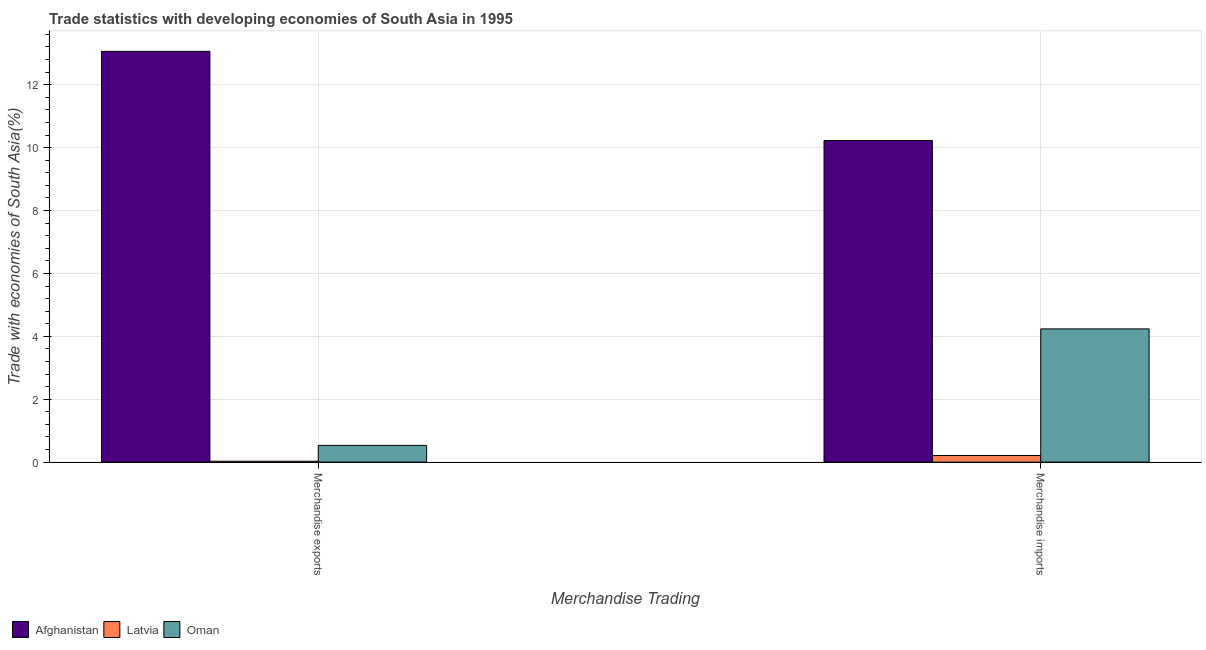How many groups of bars are there?
Give a very brief answer. 2. Are the number of bars per tick equal to the number of legend labels?
Your answer should be compact. Yes. Are the number of bars on each tick of the X-axis equal?
Provide a succinct answer. Yes. What is the label of the 2nd group of bars from the left?
Your response must be concise. Merchandise imports. What is the merchandise exports in Latvia?
Offer a terse response. 0.03. Across all countries, what is the maximum merchandise imports?
Offer a very short reply. 10.23. Across all countries, what is the minimum merchandise exports?
Your answer should be very brief. 0.03. In which country was the merchandise imports maximum?
Make the answer very short. Afghanistan. In which country was the merchandise imports minimum?
Your answer should be compact. Latvia. What is the total merchandise exports in the graph?
Ensure brevity in your answer.  13.62. What is the difference between the merchandise imports in Afghanistan and that in Latvia?
Your response must be concise. 10.02. What is the difference between the merchandise exports in Afghanistan and the merchandise imports in Oman?
Ensure brevity in your answer.  8.82. What is the average merchandise imports per country?
Ensure brevity in your answer.  4.89. What is the difference between the merchandise imports and merchandise exports in Oman?
Provide a short and direct response. 3.7. In how many countries, is the merchandise imports greater than 12.8 %?
Provide a succinct answer. 0. What is the ratio of the merchandise imports in Oman to that in Latvia?
Your answer should be very brief. 20.19. What does the 1st bar from the left in Merchandise exports represents?
Your answer should be very brief. Afghanistan. What does the 1st bar from the right in Merchandise exports represents?
Your answer should be very brief. Oman. How many bars are there?
Your response must be concise. 6. How many countries are there in the graph?
Your response must be concise. 3. What is the difference between two consecutive major ticks on the Y-axis?
Keep it short and to the point. 2. Does the graph contain any zero values?
Give a very brief answer. No. Where does the legend appear in the graph?
Make the answer very short. Bottom left. How are the legend labels stacked?
Offer a terse response. Horizontal. What is the title of the graph?
Provide a succinct answer. Trade statistics with developing economies of South Asia in 1995. What is the label or title of the X-axis?
Ensure brevity in your answer.  Merchandise Trading. What is the label or title of the Y-axis?
Give a very brief answer. Trade with economies of South Asia(%). What is the Trade with economies of South Asia(%) in Afghanistan in Merchandise exports?
Your answer should be very brief. 13.06. What is the Trade with economies of South Asia(%) in Latvia in Merchandise exports?
Ensure brevity in your answer.  0.03. What is the Trade with economies of South Asia(%) in Oman in Merchandise exports?
Ensure brevity in your answer.  0.53. What is the Trade with economies of South Asia(%) in Afghanistan in Merchandise imports?
Your answer should be very brief. 10.23. What is the Trade with economies of South Asia(%) in Latvia in Merchandise imports?
Offer a terse response. 0.21. What is the Trade with economies of South Asia(%) of Oman in Merchandise imports?
Offer a very short reply. 4.24. Across all Merchandise Trading, what is the maximum Trade with economies of South Asia(%) in Afghanistan?
Give a very brief answer. 13.06. Across all Merchandise Trading, what is the maximum Trade with economies of South Asia(%) in Latvia?
Make the answer very short. 0.21. Across all Merchandise Trading, what is the maximum Trade with economies of South Asia(%) of Oman?
Offer a terse response. 4.24. Across all Merchandise Trading, what is the minimum Trade with economies of South Asia(%) in Afghanistan?
Your response must be concise. 10.23. Across all Merchandise Trading, what is the minimum Trade with economies of South Asia(%) in Latvia?
Offer a terse response. 0.03. Across all Merchandise Trading, what is the minimum Trade with economies of South Asia(%) in Oman?
Offer a very short reply. 0.53. What is the total Trade with economies of South Asia(%) of Afghanistan in the graph?
Provide a succinct answer. 23.29. What is the total Trade with economies of South Asia(%) of Latvia in the graph?
Give a very brief answer. 0.24. What is the total Trade with economies of South Asia(%) in Oman in the graph?
Make the answer very short. 4.77. What is the difference between the Trade with economies of South Asia(%) in Afghanistan in Merchandise exports and that in Merchandise imports?
Your answer should be very brief. 2.83. What is the difference between the Trade with economies of South Asia(%) in Latvia in Merchandise exports and that in Merchandise imports?
Offer a terse response. -0.18. What is the difference between the Trade with economies of South Asia(%) in Oman in Merchandise exports and that in Merchandise imports?
Your response must be concise. -3.7. What is the difference between the Trade with economies of South Asia(%) in Afghanistan in Merchandise exports and the Trade with economies of South Asia(%) in Latvia in Merchandise imports?
Offer a very short reply. 12.85. What is the difference between the Trade with economies of South Asia(%) of Afghanistan in Merchandise exports and the Trade with economies of South Asia(%) of Oman in Merchandise imports?
Your response must be concise. 8.82. What is the difference between the Trade with economies of South Asia(%) in Latvia in Merchandise exports and the Trade with economies of South Asia(%) in Oman in Merchandise imports?
Keep it short and to the point. -4.21. What is the average Trade with economies of South Asia(%) in Afghanistan per Merchandise Trading?
Your answer should be compact. 11.64. What is the average Trade with economies of South Asia(%) in Latvia per Merchandise Trading?
Offer a terse response. 0.12. What is the average Trade with economies of South Asia(%) in Oman per Merchandise Trading?
Offer a terse response. 2.38. What is the difference between the Trade with economies of South Asia(%) of Afghanistan and Trade with economies of South Asia(%) of Latvia in Merchandise exports?
Provide a short and direct response. 13.03. What is the difference between the Trade with economies of South Asia(%) of Afghanistan and Trade with economies of South Asia(%) of Oman in Merchandise exports?
Your response must be concise. 12.53. What is the difference between the Trade with economies of South Asia(%) in Latvia and Trade with economies of South Asia(%) in Oman in Merchandise exports?
Keep it short and to the point. -0.5. What is the difference between the Trade with economies of South Asia(%) of Afghanistan and Trade with economies of South Asia(%) of Latvia in Merchandise imports?
Your response must be concise. 10.02. What is the difference between the Trade with economies of South Asia(%) of Afghanistan and Trade with economies of South Asia(%) of Oman in Merchandise imports?
Provide a succinct answer. 5.99. What is the difference between the Trade with economies of South Asia(%) in Latvia and Trade with economies of South Asia(%) in Oman in Merchandise imports?
Offer a very short reply. -4.03. What is the ratio of the Trade with economies of South Asia(%) in Afghanistan in Merchandise exports to that in Merchandise imports?
Your response must be concise. 1.28. What is the ratio of the Trade with economies of South Asia(%) in Latvia in Merchandise exports to that in Merchandise imports?
Your answer should be very brief. 0.14. What is the ratio of the Trade with economies of South Asia(%) of Oman in Merchandise exports to that in Merchandise imports?
Ensure brevity in your answer.  0.13. What is the difference between the highest and the second highest Trade with economies of South Asia(%) in Afghanistan?
Make the answer very short. 2.83. What is the difference between the highest and the second highest Trade with economies of South Asia(%) in Latvia?
Ensure brevity in your answer.  0.18. What is the difference between the highest and the second highest Trade with economies of South Asia(%) in Oman?
Offer a very short reply. 3.7. What is the difference between the highest and the lowest Trade with economies of South Asia(%) of Afghanistan?
Give a very brief answer. 2.83. What is the difference between the highest and the lowest Trade with economies of South Asia(%) of Latvia?
Your response must be concise. 0.18. What is the difference between the highest and the lowest Trade with economies of South Asia(%) of Oman?
Your response must be concise. 3.7. 